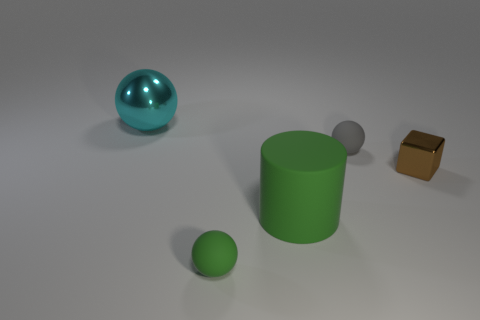How many objects are casting shadows, and what does this tell us about the lighting in the scene? All four objects are casting shadows, indicating that there’s a single light source illuminating the scene from above. The shadows are soft-edged, suggesting that the light source is not too close to the objects. 